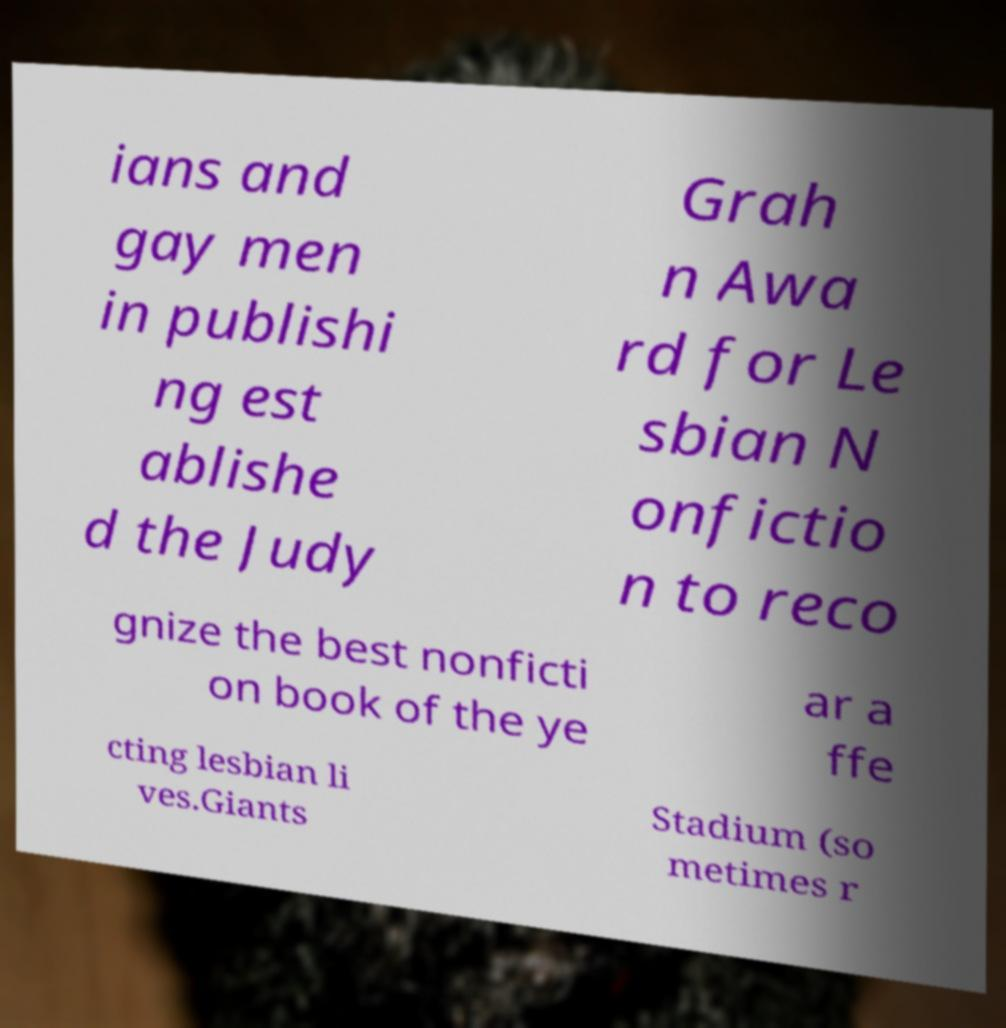What messages or text are displayed in this image? I need them in a readable, typed format. ians and gay men in publishi ng est ablishe d the Judy Grah n Awa rd for Le sbian N onfictio n to reco gnize the best nonficti on book of the ye ar a ffe cting lesbian li ves.Giants Stadium (so metimes r 